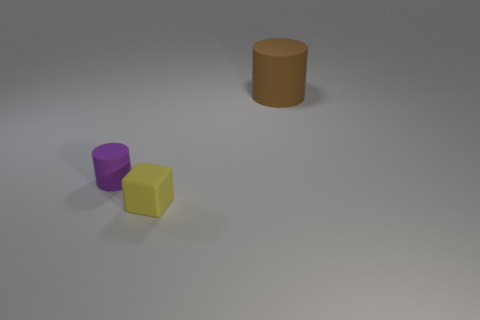Add 2 yellow matte blocks. How many objects exist? 5 Subtract all cylinders. How many objects are left? 1 Subtract 0 red cylinders. How many objects are left? 3 Subtract all tiny things. Subtract all tiny red rubber cylinders. How many objects are left? 1 Add 1 large cylinders. How many large cylinders are left? 2 Add 3 large objects. How many large objects exist? 4 